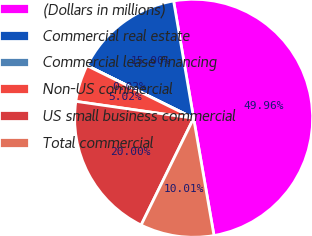Convert chart to OTSL. <chart><loc_0><loc_0><loc_500><loc_500><pie_chart><fcel>(Dollars in millions)<fcel>Commercial real estate<fcel>Commercial lease financing<fcel>Non-US commercial<fcel>US small business commercial<fcel>Total commercial<nl><fcel>49.96%<fcel>15.0%<fcel>0.02%<fcel>5.02%<fcel>20.0%<fcel>10.01%<nl></chart> 